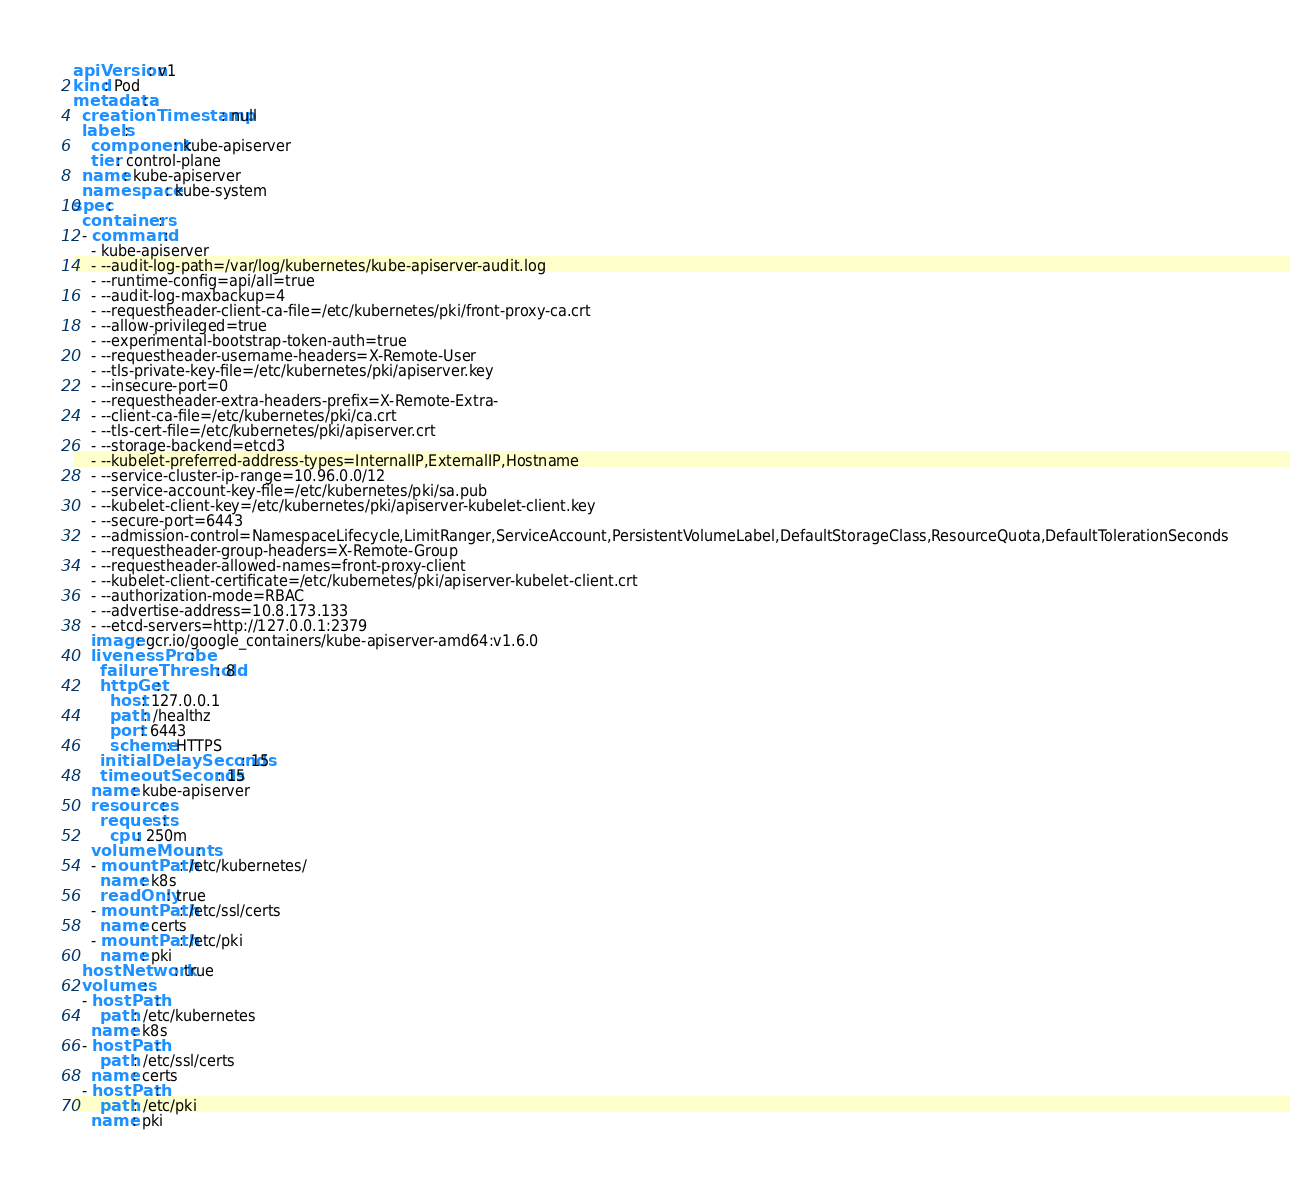<code> <loc_0><loc_0><loc_500><loc_500><_YAML_>apiVersion: v1
kind: Pod
metadata:
  creationTimestamp: null
  labels:
    component: kube-apiserver
    tier: control-plane
  name: kube-apiserver
  namespace: kube-system
spec:
  containers:
  - command:
    - kube-apiserver
    - --audit-log-path=/var/log/kubernetes/kube-apiserver-audit.log
    - --runtime-config=api/all=true
    - --audit-log-maxbackup=4
    - --requestheader-client-ca-file=/etc/kubernetes/pki/front-proxy-ca.crt
    - --allow-privileged=true
    - --experimental-bootstrap-token-auth=true
    - --requestheader-username-headers=X-Remote-User
    - --tls-private-key-file=/etc/kubernetes/pki/apiserver.key
    - --insecure-port=0
    - --requestheader-extra-headers-prefix=X-Remote-Extra-
    - --client-ca-file=/etc/kubernetes/pki/ca.crt
    - --tls-cert-file=/etc/kubernetes/pki/apiserver.crt
    - --storage-backend=etcd3
    - --kubelet-preferred-address-types=InternalIP,ExternalIP,Hostname
    - --service-cluster-ip-range=10.96.0.0/12
    - --service-account-key-file=/etc/kubernetes/pki/sa.pub
    - --kubelet-client-key=/etc/kubernetes/pki/apiserver-kubelet-client.key
    - --secure-port=6443
    - --admission-control=NamespaceLifecycle,LimitRanger,ServiceAccount,PersistentVolumeLabel,DefaultStorageClass,ResourceQuota,DefaultTolerationSeconds
    - --requestheader-group-headers=X-Remote-Group
    - --requestheader-allowed-names=front-proxy-client
    - --kubelet-client-certificate=/etc/kubernetes/pki/apiserver-kubelet-client.crt
    - --authorization-mode=RBAC
    - --advertise-address=10.8.173.133
    - --etcd-servers=http://127.0.0.1:2379
    image: gcr.io/google_containers/kube-apiserver-amd64:v1.6.0
    livenessProbe:
      failureThreshold: 8
      httpGet:
        host: 127.0.0.1
        path: /healthz
        port: 6443
        scheme: HTTPS
      initialDelaySeconds: 15
      timeoutSeconds: 15
    name: kube-apiserver
    resources:
      requests:
        cpu: 250m
    volumeMounts:
    - mountPath: /etc/kubernetes/
      name: k8s
      readOnly: true
    - mountPath: /etc/ssl/certs
      name: certs
    - mountPath: /etc/pki
      name: pki
  hostNetwork: true
  volumes:
  - hostPath:
      path: /etc/kubernetes
    name: k8s
  - hostPath:
      path: /etc/ssl/certs
    name: certs
  - hostPath:
      path: /etc/pki
    name: pki
</code> 